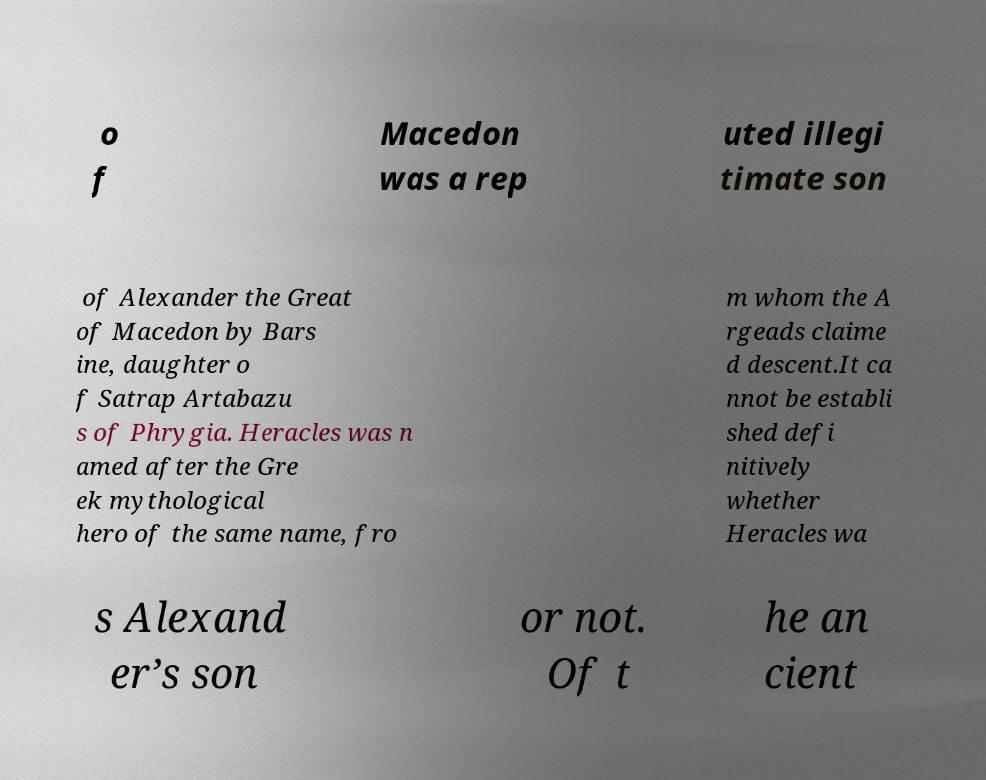Please read and relay the text visible in this image. What does it say? o f Macedon was a rep uted illegi timate son of Alexander the Great of Macedon by Bars ine, daughter o f Satrap Artabazu s of Phrygia. Heracles was n amed after the Gre ek mythological hero of the same name, fro m whom the A rgeads claime d descent.It ca nnot be establi shed defi nitively whether Heracles wa s Alexand er’s son or not. Of t he an cient 